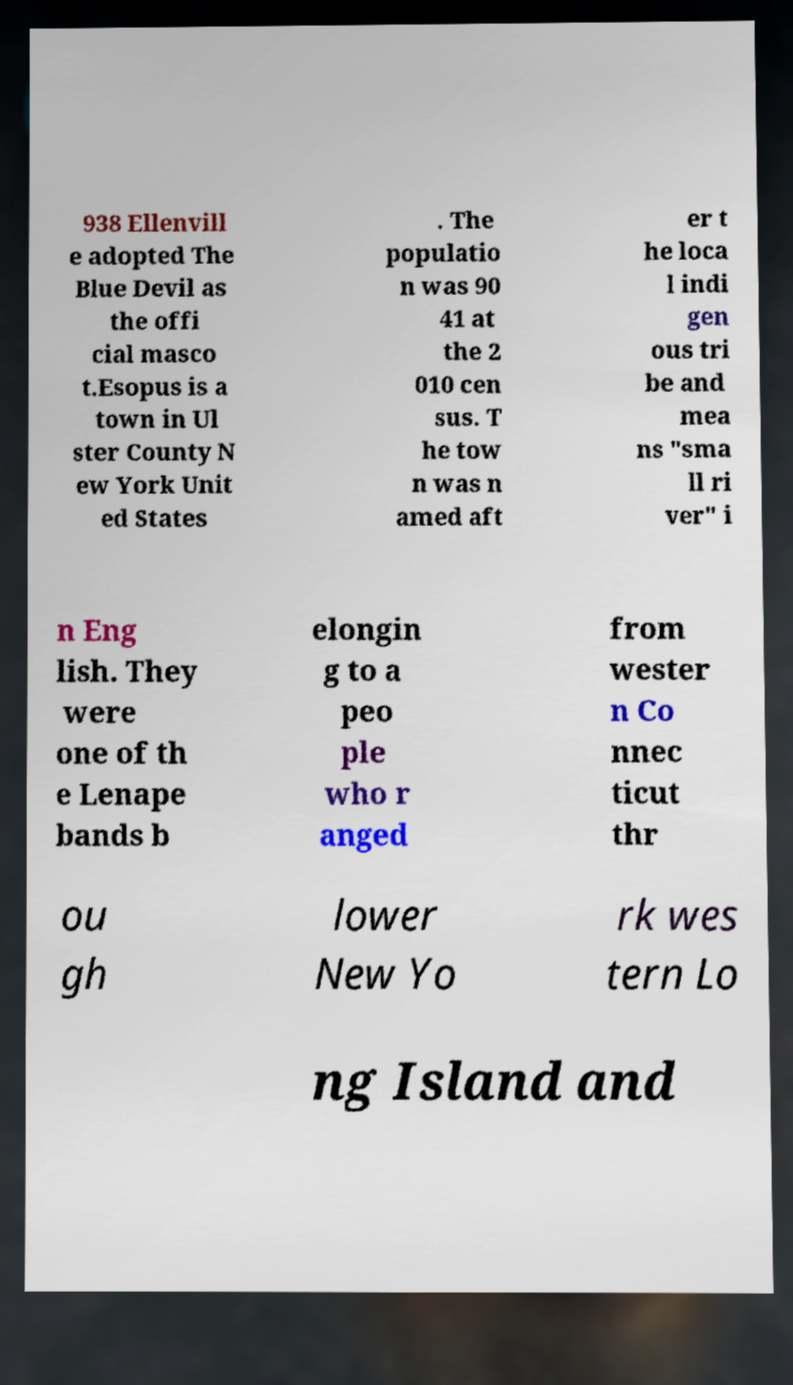Could you assist in decoding the text presented in this image and type it out clearly? 938 Ellenvill e adopted The Blue Devil as the offi cial masco t.Esopus is a town in Ul ster County N ew York Unit ed States . The populatio n was 90 41 at the 2 010 cen sus. T he tow n was n amed aft er t he loca l indi gen ous tri be and mea ns "sma ll ri ver" i n Eng lish. They were one of th e Lenape bands b elongin g to a peo ple who r anged from wester n Co nnec ticut thr ou gh lower New Yo rk wes tern Lo ng Island and 